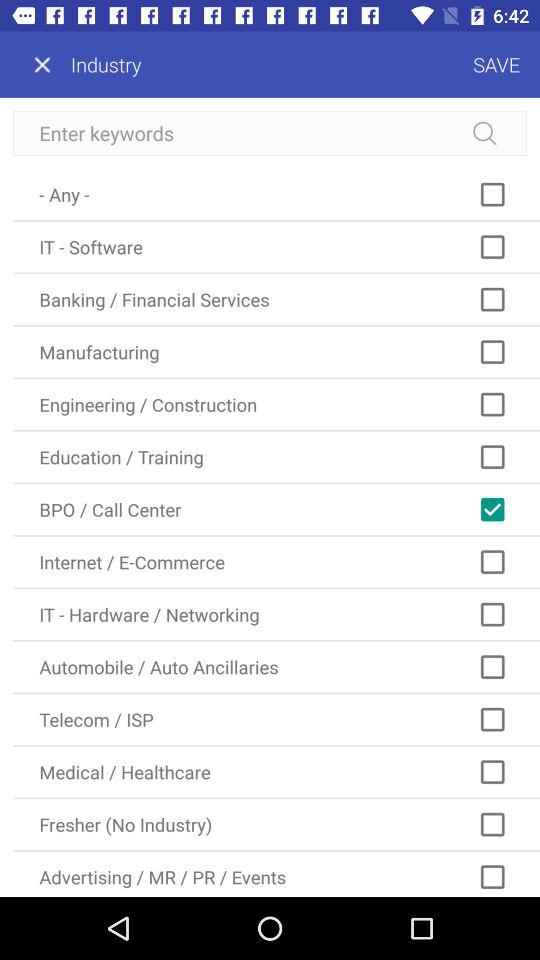What are the different available industry options? The different available industry options are "- Any -", "IT - Software", "Banking / Financial Services", "Manufacturing", "Engineering / Construction", "Education / Training", "BPO / Call Center", "Internet / E-Commerce", "IT - Hardware / Networking", "Automobile / Auto Ancillaries", "Telecom / ISP", "Medical / Healthcare", "Fresher (No Industry)" and "Advertising / MR / PR / Events". 